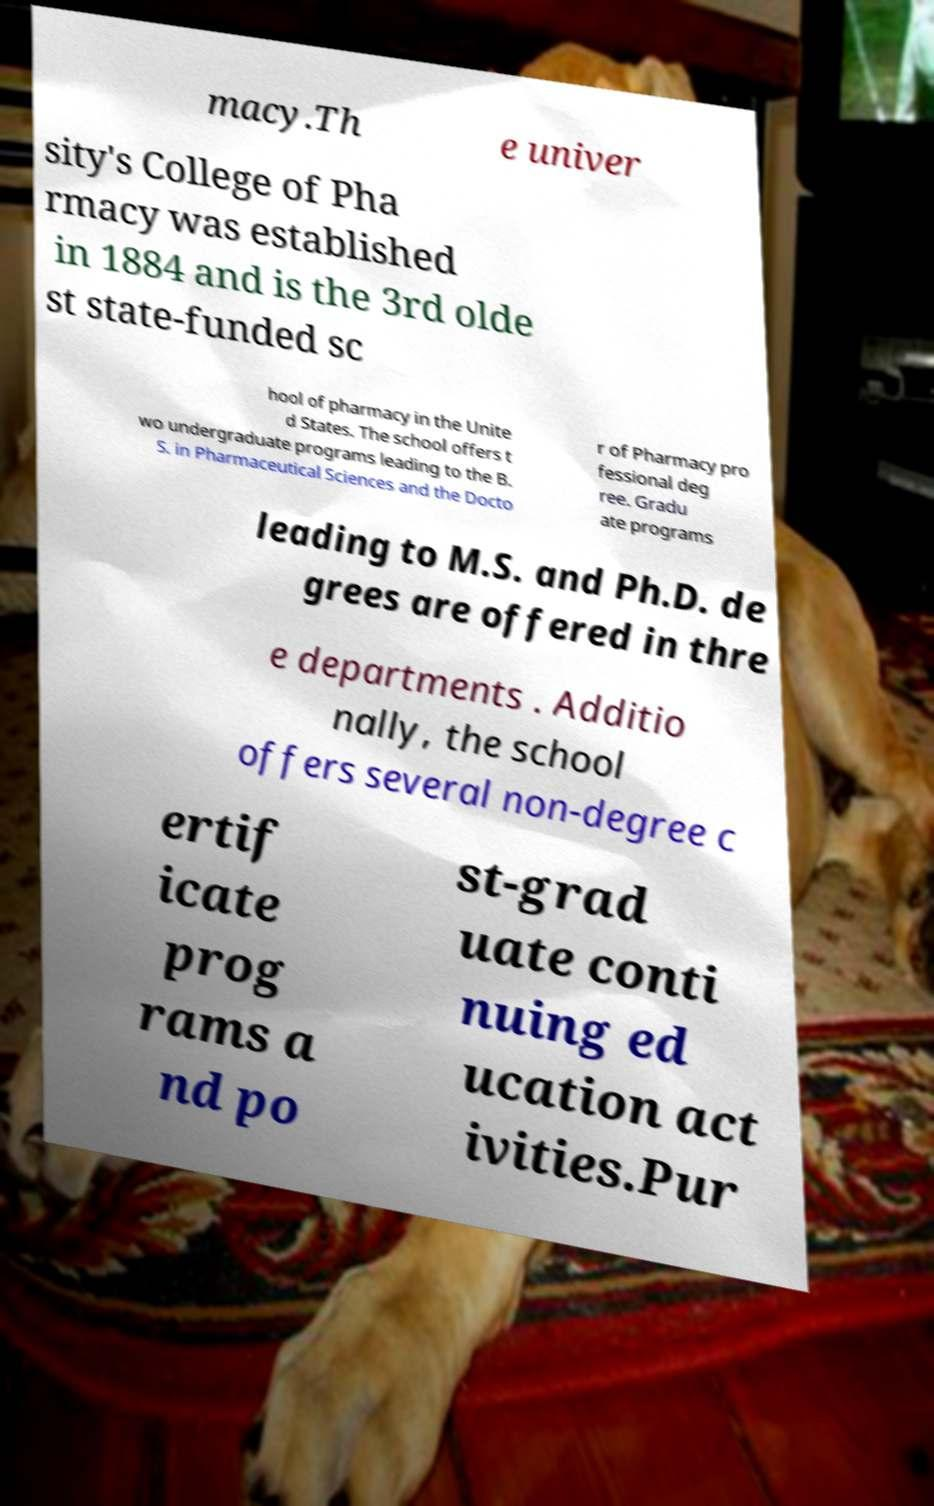Please read and relay the text visible in this image. What does it say? macy.Th e univer sity's College of Pha rmacy was established in 1884 and is the 3rd olde st state-funded sc hool of pharmacy in the Unite d States. The school offers t wo undergraduate programs leading to the B. S. in Pharmaceutical Sciences and the Docto r of Pharmacy pro fessional deg ree. Gradu ate programs leading to M.S. and Ph.D. de grees are offered in thre e departments . Additio nally, the school offers several non-degree c ertif icate prog rams a nd po st-grad uate conti nuing ed ucation act ivities.Pur 